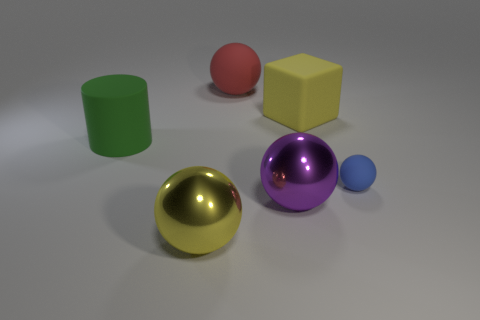Is the number of blue matte balls greater than the number of tiny red rubber cubes?
Give a very brief answer. Yes. What number of other things are the same color as the small matte thing?
Provide a succinct answer. 0. How many big purple things are behind the rubber ball behind the small ball?
Keep it short and to the point. 0. There is a red matte object; are there any large things on the left side of it?
Offer a terse response. Yes. The yellow object that is behind the matte thing to the right of the big yellow block is what shape?
Your answer should be very brief. Cube. Are there fewer yellow cubes that are behind the red thing than tiny blue rubber things that are in front of the small matte ball?
Make the answer very short. No. There is another matte thing that is the same shape as the small matte thing; what is its color?
Provide a short and direct response. Red. What number of things are in front of the yellow cube and right of the big red sphere?
Your answer should be very brief. 2. Are there more small balls in front of the small blue matte ball than large matte spheres that are in front of the large cylinder?
Your response must be concise. No. What is the size of the yellow metallic sphere?
Keep it short and to the point. Large. 